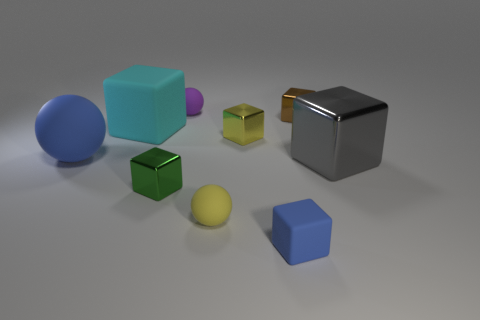Subtract all tiny yellow rubber spheres. How many spheres are left? 2 Subtract all gray blocks. How many blocks are left? 5 Subtract 2 spheres. How many spheres are left? 1 Subtract all yellow blocks. Subtract all blue cylinders. How many blocks are left? 5 Subtract all yellow balls. How many gray cubes are left? 1 Subtract all tiny yellow shiny spheres. Subtract all brown metallic objects. How many objects are left? 8 Add 2 green metallic objects. How many green metallic objects are left? 3 Add 7 big shiny objects. How many big shiny objects exist? 8 Subtract 0 red balls. How many objects are left? 9 Subtract all balls. How many objects are left? 6 